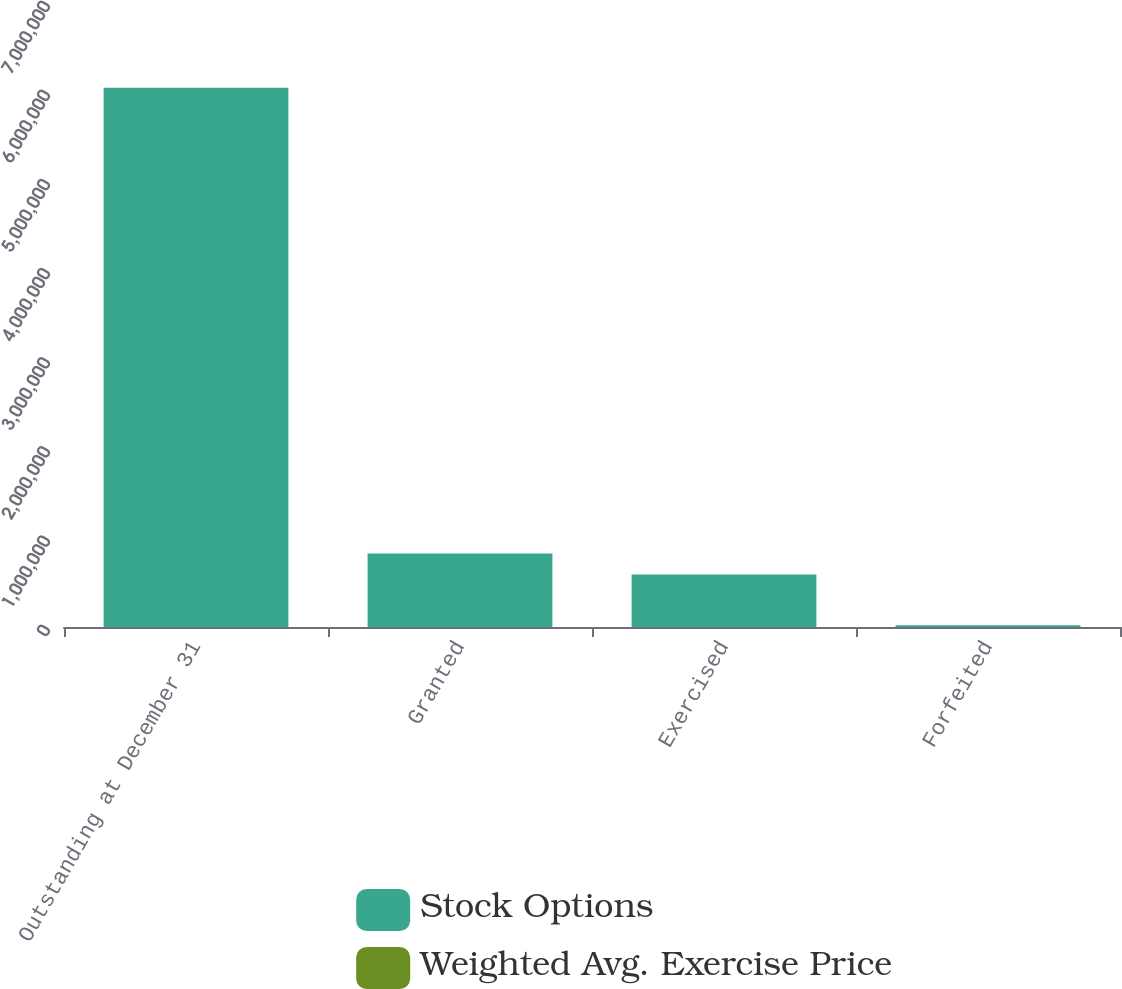<chart> <loc_0><loc_0><loc_500><loc_500><stacked_bar_chart><ecel><fcel>Outstanding at December 31<fcel>Granted<fcel>Exercised<fcel>Forfeited<nl><fcel>Stock Options<fcel>6.04874e+06<fcel>825210<fcel>589081<fcel>18710<nl><fcel>Weighted Avg. Exercise Price<fcel>67.9<fcel>102.38<fcel>52.99<fcel>86.7<nl></chart> 